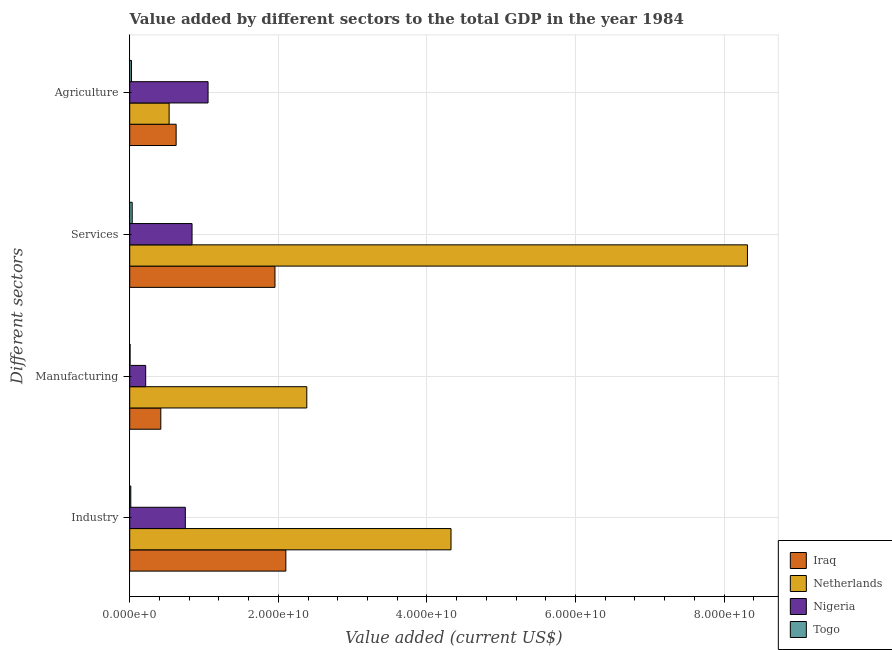How many groups of bars are there?
Your answer should be compact. 4. Are the number of bars on each tick of the Y-axis equal?
Your answer should be very brief. Yes. How many bars are there on the 4th tick from the bottom?
Provide a short and direct response. 4. What is the label of the 3rd group of bars from the top?
Provide a succinct answer. Manufacturing. What is the value added by services sector in Nigeria?
Your answer should be compact. 8.39e+09. Across all countries, what is the maximum value added by services sector?
Your response must be concise. 8.31e+1. Across all countries, what is the minimum value added by services sector?
Give a very brief answer. 3.33e+08. In which country was the value added by services sector maximum?
Your answer should be very brief. Netherlands. In which country was the value added by agricultural sector minimum?
Your response must be concise. Togo. What is the total value added by industrial sector in the graph?
Offer a very short reply. 7.19e+1. What is the difference between the value added by manufacturing sector in Togo and that in Netherlands?
Provide a short and direct response. -2.38e+1. What is the difference between the value added by services sector in Nigeria and the value added by agricultural sector in Iraq?
Ensure brevity in your answer.  2.14e+09. What is the average value added by agricultural sector per country?
Provide a short and direct response. 5.58e+09. What is the difference between the value added by services sector and value added by manufacturing sector in Togo?
Provide a short and direct response. 2.87e+08. In how many countries, is the value added by industrial sector greater than 4000000000 US$?
Your response must be concise. 3. What is the ratio of the value added by services sector in Iraq to that in Nigeria?
Provide a succinct answer. 2.33. What is the difference between the highest and the second highest value added by industrial sector?
Provide a succinct answer. 2.22e+1. What is the difference between the highest and the lowest value added by manufacturing sector?
Your answer should be compact. 2.38e+1. In how many countries, is the value added by industrial sector greater than the average value added by industrial sector taken over all countries?
Make the answer very short. 2. Is it the case that in every country, the sum of the value added by manufacturing sector and value added by agricultural sector is greater than the sum of value added by industrial sector and value added by services sector?
Keep it short and to the point. No. What does the 4th bar from the top in Agriculture represents?
Keep it short and to the point. Iraq. What does the 4th bar from the bottom in Manufacturing represents?
Provide a short and direct response. Togo. Is it the case that in every country, the sum of the value added by industrial sector and value added by manufacturing sector is greater than the value added by services sector?
Keep it short and to the point. No. How many bars are there?
Offer a terse response. 16. Are all the bars in the graph horizontal?
Offer a terse response. Yes. What is the difference between two consecutive major ticks on the X-axis?
Your response must be concise. 2.00e+1. Are the values on the major ticks of X-axis written in scientific E-notation?
Give a very brief answer. Yes. Does the graph contain any zero values?
Offer a very short reply. No. How many legend labels are there?
Keep it short and to the point. 4. What is the title of the graph?
Provide a short and direct response. Value added by different sectors to the total GDP in the year 1984. Does "Costa Rica" appear as one of the legend labels in the graph?
Make the answer very short. No. What is the label or title of the X-axis?
Your answer should be compact. Value added (current US$). What is the label or title of the Y-axis?
Your answer should be very brief. Different sectors. What is the Value added (current US$) of Iraq in Industry?
Make the answer very short. 2.10e+1. What is the Value added (current US$) of Netherlands in Industry?
Make the answer very short. 4.32e+1. What is the Value added (current US$) in Nigeria in Industry?
Offer a terse response. 7.48e+09. What is the Value added (current US$) of Togo in Industry?
Offer a very short reply. 1.45e+08. What is the Value added (current US$) of Iraq in Manufacturing?
Your response must be concise. 4.18e+09. What is the Value added (current US$) in Netherlands in Manufacturing?
Keep it short and to the point. 2.38e+1. What is the Value added (current US$) in Nigeria in Manufacturing?
Your answer should be very brief. 2.15e+09. What is the Value added (current US$) of Togo in Manufacturing?
Offer a terse response. 4.58e+07. What is the Value added (current US$) of Iraq in Services?
Your answer should be compact. 1.95e+1. What is the Value added (current US$) in Netherlands in Services?
Your answer should be compact. 8.31e+1. What is the Value added (current US$) of Nigeria in Services?
Offer a very short reply. 8.39e+09. What is the Value added (current US$) of Togo in Services?
Offer a very short reply. 3.33e+08. What is the Value added (current US$) in Iraq in Agriculture?
Your answer should be very brief. 6.25e+09. What is the Value added (current US$) of Netherlands in Agriculture?
Your answer should be very brief. 5.30e+09. What is the Value added (current US$) in Nigeria in Agriculture?
Your response must be concise. 1.05e+1. What is the Value added (current US$) in Togo in Agriculture?
Your answer should be compact. 2.40e+08. Across all Different sectors, what is the maximum Value added (current US$) in Iraq?
Your answer should be compact. 2.10e+1. Across all Different sectors, what is the maximum Value added (current US$) of Netherlands?
Provide a succinct answer. 8.31e+1. Across all Different sectors, what is the maximum Value added (current US$) in Nigeria?
Give a very brief answer. 1.05e+1. Across all Different sectors, what is the maximum Value added (current US$) of Togo?
Your answer should be very brief. 3.33e+08. Across all Different sectors, what is the minimum Value added (current US$) of Iraq?
Your answer should be very brief. 4.18e+09. Across all Different sectors, what is the minimum Value added (current US$) of Netherlands?
Ensure brevity in your answer.  5.30e+09. Across all Different sectors, what is the minimum Value added (current US$) in Nigeria?
Provide a short and direct response. 2.15e+09. Across all Different sectors, what is the minimum Value added (current US$) of Togo?
Make the answer very short. 4.58e+07. What is the total Value added (current US$) in Iraq in the graph?
Provide a short and direct response. 5.10e+1. What is the total Value added (current US$) of Netherlands in the graph?
Make the answer very short. 1.56e+11. What is the total Value added (current US$) of Nigeria in the graph?
Keep it short and to the point. 2.86e+1. What is the total Value added (current US$) of Togo in the graph?
Give a very brief answer. 7.64e+08. What is the difference between the Value added (current US$) in Iraq in Industry and that in Manufacturing?
Provide a short and direct response. 1.68e+1. What is the difference between the Value added (current US$) in Netherlands in Industry and that in Manufacturing?
Ensure brevity in your answer.  1.94e+1. What is the difference between the Value added (current US$) of Nigeria in Industry and that in Manufacturing?
Ensure brevity in your answer.  5.34e+09. What is the difference between the Value added (current US$) of Togo in Industry and that in Manufacturing?
Provide a succinct answer. 9.93e+07. What is the difference between the Value added (current US$) of Iraq in Industry and that in Services?
Make the answer very short. 1.46e+09. What is the difference between the Value added (current US$) of Netherlands in Industry and that in Services?
Keep it short and to the point. -3.99e+1. What is the difference between the Value added (current US$) of Nigeria in Industry and that in Services?
Give a very brief answer. -9.04e+08. What is the difference between the Value added (current US$) in Togo in Industry and that in Services?
Ensure brevity in your answer.  -1.88e+08. What is the difference between the Value added (current US$) of Iraq in Industry and that in Agriculture?
Give a very brief answer. 1.48e+1. What is the difference between the Value added (current US$) of Netherlands in Industry and that in Agriculture?
Provide a short and direct response. 3.79e+1. What is the difference between the Value added (current US$) in Nigeria in Industry and that in Agriculture?
Ensure brevity in your answer.  -3.06e+09. What is the difference between the Value added (current US$) of Togo in Industry and that in Agriculture?
Provide a succinct answer. -9.52e+07. What is the difference between the Value added (current US$) in Iraq in Manufacturing and that in Services?
Offer a very short reply. -1.54e+1. What is the difference between the Value added (current US$) of Netherlands in Manufacturing and that in Services?
Your response must be concise. -5.93e+1. What is the difference between the Value added (current US$) in Nigeria in Manufacturing and that in Services?
Your answer should be very brief. -6.24e+09. What is the difference between the Value added (current US$) in Togo in Manufacturing and that in Services?
Your answer should be compact. -2.87e+08. What is the difference between the Value added (current US$) in Iraq in Manufacturing and that in Agriculture?
Give a very brief answer. -2.06e+09. What is the difference between the Value added (current US$) in Netherlands in Manufacturing and that in Agriculture?
Keep it short and to the point. 1.85e+1. What is the difference between the Value added (current US$) in Nigeria in Manufacturing and that in Agriculture?
Your response must be concise. -8.40e+09. What is the difference between the Value added (current US$) of Togo in Manufacturing and that in Agriculture?
Keep it short and to the point. -1.95e+08. What is the difference between the Value added (current US$) of Iraq in Services and that in Agriculture?
Your answer should be very brief. 1.33e+1. What is the difference between the Value added (current US$) in Netherlands in Services and that in Agriculture?
Make the answer very short. 7.78e+1. What is the difference between the Value added (current US$) of Nigeria in Services and that in Agriculture?
Your answer should be very brief. -2.16e+09. What is the difference between the Value added (current US$) of Togo in Services and that in Agriculture?
Your answer should be very brief. 9.25e+07. What is the difference between the Value added (current US$) of Iraq in Industry and the Value added (current US$) of Netherlands in Manufacturing?
Provide a short and direct response. -2.82e+09. What is the difference between the Value added (current US$) of Iraq in Industry and the Value added (current US$) of Nigeria in Manufacturing?
Ensure brevity in your answer.  1.89e+1. What is the difference between the Value added (current US$) of Iraq in Industry and the Value added (current US$) of Togo in Manufacturing?
Offer a very short reply. 2.10e+1. What is the difference between the Value added (current US$) of Netherlands in Industry and the Value added (current US$) of Nigeria in Manufacturing?
Give a very brief answer. 4.11e+1. What is the difference between the Value added (current US$) of Netherlands in Industry and the Value added (current US$) of Togo in Manufacturing?
Keep it short and to the point. 4.32e+1. What is the difference between the Value added (current US$) of Nigeria in Industry and the Value added (current US$) of Togo in Manufacturing?
Offer a terse response. 7.44e+09. What is the difference between the Value added (current US$) in Iraq in Industry and the Value added (current US$) in Netherlands in Services?
Provide a short and direct response. -6.21e+1. What is the difference between the Value added (current US$) in Iraq in Industry and the Value added (current US$) in Nigeria in Services?
Your answer should be very brief. 1.26e+1. What is the difference between the Value added (current US$) of Iraq in Industry and the Value added (current US$) of Togo in Services?
Your response must be concise. 2.07e+1. What is the difference between the Value added (current US$) of Netherlands in Industry and the Value added (current US$) of Nigeria in Services?
Ensure brevity in your answer.  3.49e+1. What is the difference between the Value added (current US$) of Netherlands in Industry and the Value added (current US$) of Togo in Services?
Give a very brief answer. 4.29e+1. What is the difference between the Value added (current US$) in Nigeria in Industry and the Value added (current US$) in Togo in Services?
Your answer should be compact. 7.15e+09. What is the difference between the Value added (current US$) in Iraq in Industry and the Value added (current US$) in Netherlands in Agriculture?
Your response must be concise. 1.57e+1. What is the difference between the Value added (current US$) of Iraq in Industry and the Value added (current US$) of Nigeria in Agriculture?
Keep it short and to the point. 1.05e+1. What is the difference between the Value added (current US$) of Iraq in Industry and the Value added (current US$) of Togo in Agriculture?
Offer a terse response. 2.08e+1. What is the difference between the Value added (current US$) in Netherlands in Industry and the Value added (current US$) in Nigeria in Agriculture?
Your answer should be very brief. 3.27e+1. What is the difference between the Value added (current US$) of Netherlands in Industry and the Value added (current US$) of Togo in Agriculture?
Your answer should be compact. 4.30e+1. What is the difference between the Value added (current US$) in Nigeria in Industry and the Value added (current US$) in Togo in Agriculture?
Give a very brief answer. 7.24e+09. What is the difference between the Value added (current US$) of Iraq in Manufacturing and the Value added (current US$) of Netherlands in Services?
Your response must be concise. -7.90e+1. What is the difference between the Value added (current US$) of Iraq in Manufacturing and the Value added (current US$) of Nigeria in Services?
Ensure brevity in your answer.  -4.20e+09. What is the difference between the Value added (current US$) of Iraq in Manufacturing and the Value added (current US$) of Togo in Services?
Provide a succinct answer. 3.85e+09. What is the difference between the Value added (current US$) in Netherlands in Manufacturing and the Value added (current US$) in Nigeria in Services?
Make the answer very short. 1.54e+1. What is the difference between the Value added (current US$) of Netherlands in Manufacturing and the Value added (current US$) of Togo in Services?
Keep it short and to the point. 2.35e+1. What is the difference between the Value added (current US$) in Nigeria in Manufacturing and the Value added (current US$) in Togo in Services?
Offer a very short reply. 1.82e+09. What is the difference between the Value added (current US$) of Iraq in Manufacturing and the Value added (current US$) of Netherlands in Agriculture?
Make the answer very short. -1.12e+09. What is the difference between the Value added (current US$) in Iraq in Manufacturing and the Value added (current US$) in Nigeria in Agriculture?
Keep it short and to the point. -6.36e+09. What is the difference between the Value added (current US$) in Iraq in Manufacturing and the Value added (current US$) in Togo in Agriculture?
Provide a succinct answer. 3.94e+09. What is the difference between the Value added (current US$) in Netherlands in Manufacturing and the Value added (current US$) in Nigeria in Agriculture?
Ensure brevity in your answer.  1.33e+1. What is the difference between the Value added (current US$) in Netherlands in Manufacturing and the Value added (current US$) in Togo in Agriculture?
Provide a succinct answer. 2.36e+1. What is the difference between the Value added (current US$) in Nigeria in Manufacturing and the Value added (current US$) in Togo in Agriculture?
Provide a succinct answer. 1.91e+09. What is the difference between the Value added (current US$) in Iraq in Services and the Value added (current US$) in Netherlands in Agriculture?
Keep it short and to the point. 1.42e+1. What is the difference between the Value added (current US$) in Iraq in Services and the Value added (current US$) in Nigeria in Agriculture?
Your answer should be very brief. 9.01e+09. What is the difference between the Value added (current US$) in Iraq in Services and the Value added (current US$) in Togo in Agriculture?
Keep it short and to the point. 1.93e+1. What is the difference between the Value added (current US$) in Netherlands in Services and the Value added (current US$) in Nigeria in Agriculture?
Provide a succinct answer. 7.26e+1. What is the difference between the Value added (current US$) in Netherlands in Services and the Value added (current US$) in Togo in Agriculture?
Give a very brief answer. 8.29e+1. What is the difference between the Value added (current US$) of Nigeria in Services and the Value added (current US$) of Togo in Agriculture?
Keep it short and to the point. 8.15e+09. What is the average Value added (current US$) of Iraq per Different sectors?
Your answer should be compact. 1.27e+1. What is the average Value added (current US$) of Netherlands per Different sectors?
Provide a short and direct response. 3.89e+1. What is the average Value added (current US$) in Nigeria per Different sectors?
Your answer should be very brief. 7.14e+09. What is the average Value added (current US$) in Togo per Different sectors?
Give a very brief answer. 1.91e+08. What is the difference between the Value added (current US$) of Iraq and Value added (current US$) of Netherlands in Industry?
Keep it short and to the point. -2.22e+1. What is the difference between the Value added (current US$) of Iraq and Value added (current US$) of Nigeria in Industry?
Make the answer very short. 1.35e+1. What is the difference between the Value added (current US$) in Iraq and Value added (current US$) in Togo in Industry?
Your response must be concise. 2.09e+1. What is the difference between the Value added (current US$) of Netherlands and Value added (current US$) of Nigeria in Industry?
Keep it short and to the point. 3.58e+1. What is the difference between the Value added (current US$) in Netherlands and Value added (current US$) in Togo in Industry?
Keep it short and to the point. 4.31e+1. What is the difference between the Value added (current US$) of Nigeria and Value added (current US$) of Togo in Industry?
Give a very brief answer. 7.34e+09. What is the difference between the Value added (current US$) of Iraq and Value added (current US$) of Netherlands in Manufacturing?
Offer a very short reply. -1.96e+1. What is the difference between the Value added (current US$) in Iraq and Value added (current US$) in Nigeria in Manufacturing?
Ensure brevity in your answer.  2.04e+09. What is the difference between the Value added (current US$) of Iraq and Value added (current US$) of Togo in Manufacturing?
Provide a short and direct response. 4.14e+09. What is the difference between the Value added (current US$) of Netherlands and Value added (current US$) of Nigeria in Manufacturing?
Provide a succinct answer. 2.17e+1. What is the difference between the Value added (current US$) of Netherlands and Value added (current US$) of Togo in Manufacturing?
Make the answer very short. 2.38e+1. What is the difference between the Value added (current US$) in Nigeria and Value added (current US$) in Togo in Manufacturing?
Provide a succinct answer. 2.10e+09. What is the difference between the Value added (current US$) in Iraq and Value added (current US$) in Netherlands in Services?
Your answer should be very brief. -6.36e+1. What is the difference between the Value added (current US$) of Iraq and Value added (current US$) of Nigeria in Services?
Offer a terse response. 1.12e+1. What is the difference between the Value added (current US$) in Iraq and Value added (current US$) in Togo in Services?
Offer a very short reply. 1.92e+1. What is the difference between the Value added (current US$) in Netherlands and Value added (current US$) in Nigeria in Services?
Keep it short and to the point. 7.48e+1. What is the difference between the Value added (current US$) of Netherlands and Value added (current US$) of Togo in Services?
Make the answer very short. 8.28e+1. What is the difference between the Value added (current US$) in Nigeria and Value added (current US$) in Togo in Services?
Offer a terse response. 8.06e+09. What is the difference between the Value added (current US$) in Iraq and Value added (current US$) in Netherlands in Agriculture?
Your answer should be very brief. 9.43e+08. What is the difference between the Value added (current US$) of Iraq and Value added (current US$) of Nigeria in Agriculture?
Make the answer very short. -4.30e+09. What is the difference between the Value added (current US$) in Iraq and Value added (current US$) in Togo in Agriculture?
Offer a very short reply. 6.01e+09. What is the difference between the Value added (current US$) in Netherlands and Value added (current US$) in Nigeria in Agriculture?
Give a very brief answer. -5.24e+09. What is the difference between the Value added (current US$) in Netherlands and Value added (current US$) in Togo in Agriculture?
Provide a succinct answer. 5.06e+09. What is the difference between the Value added (current US$) in Nigeria and Value added (current US$) in Togo in Agriculture?
Keep it short and to the point. 1.03e+1. What is the ratio of the Value added (current US$) of Iraq in Industry to that in Manufacturing?
Provide a short and direct response. 5.02. What is the ratio of the Value added (current US$) in Netherlands in Industry to that in Manufacturing?
Keep it short and to the point. 1.81. What is the ratio of the Value added (current US$) in Nigeria in Industry to that in Manufacturing?
Ensure brevity in your answer.  3.48. What is the ratio of the Value added (current US$) in Togo in Industry to that in Manufacturing?
Provide a succinct answer. 3.17. What is the ratio of the Value added (current US$) of Iraq in Industry to that in Services?
Provide a short and direct response. 1.07. What is the ratio of the Value added (current US$) of Netherlands in Industry to that in Services?
Keep it short and to the point. 0.52. What is the ratio of the Value added (current US$) of Nigeria in Industry to that in Services?
Keep it short and to the point. 0.89. What is the ratio of the Value added (current US$) of Togo in Industry to that in Services?
Your answer should be very brief. 0.44. What is the ratio of the Value added (current US$) in Iraq in Industry to that in Agriculture?
Ensure brevity in your answer.  3.36. What is the ratio of the Value added (current US$) of Netherlands in Industry to that in Agriculture?
Your answer should be very brief. 8.15. What is the ratio of the Value added (current US$) in Nigeria in Industry to that in Agriculture?
Ensure brevity in your answer.  0.71. What is the ratio of the Value added (current US$) in Togo in Industry to that in Agriculture?
Provide a succinct answer. 0.6. What is the ratio of the Value added (current US$) of Iraq in Manufacturing to that in Services?
Make the answer very short. 0.21. What is the ratio of the Value added (current US$) in Netherlands in Manufacturing to that in Services?
Offer a terse response. 0.29. What is the ratio of the Value added (current US$) in Nigeria in Manufacturing to that in Services?
Offer a very short reply. 0.26. What is the ratio of the Value added (current US$) in Togo in Manufacturing to that in Services?
Your answer should be compact. 0.14. What is the ratio of the Value added (current US$) of Iraq in Manufacturing to that in Agriculture?
Your answer should be compact. 0.67. What is the ratio of the Value added (current US$) of Netherlands in Manufacturing to that in Agriculture?
Offer a terse response. 4.49. What is the ratio of the Value added (current US$) in Nigeria in Manufacturing to that in Agriculture?
Your response must be concise. 0.2. What is the ratio of the Value added (current US$) of Togo in Manufacturing to that in Agriculture?
Provide a succinct answer. 0.19. What is the ratio of the Value added (current US$) of Iraq in Services to that in Agriculture?
Make the answer very short. 3.13. What is the ratio of the Value added (current US$) of Netherlands in Services to that in Agriculture?
Provide a succinct answer. 15.68. What is the ratio of the Value added (current US$) in Nigeria in Services to that in Agriculture?
Provide a short and direct response. 0.8. What is the ratio of the Value added (current US$) of Togo in Services to that in Agriculture?
Offer a very short reply. 1.38. What is the difference between the highest and the second highest Value added (current US$) of Iraq?
Your answer should be compact. 1.46e+09. What is the difference between the highest and the second highest Value added (current US$) in Netherlands?
Offer a very short reply. 3.99e+1. What is the difference between the highest and the second highest Value added (current US$) in Nigeria?
Offer a very short reply. 2.16e+09. What is the difference between the highest and the second highest Value added (current US$) of Togo?
Your answer should be compact. 9.25e+07. What is the difference between the highest and the lowest Value added (current US$) in Iraq?
Provide a short and direct response. 1.68e+1. What is the difference between the highest and the lowest Value added (current US$) of Netherlands?
Provide a succinct answer. 7.78e+1. What is the difference between the highest and the lowest Value added (current US$) of Nigeria?
Provide a succinct answer. 8.40e+09. What is the difference between the highest and the lowest Value added (current US$) in Togo?
Provide a short and direct response. 2.87e+08. 